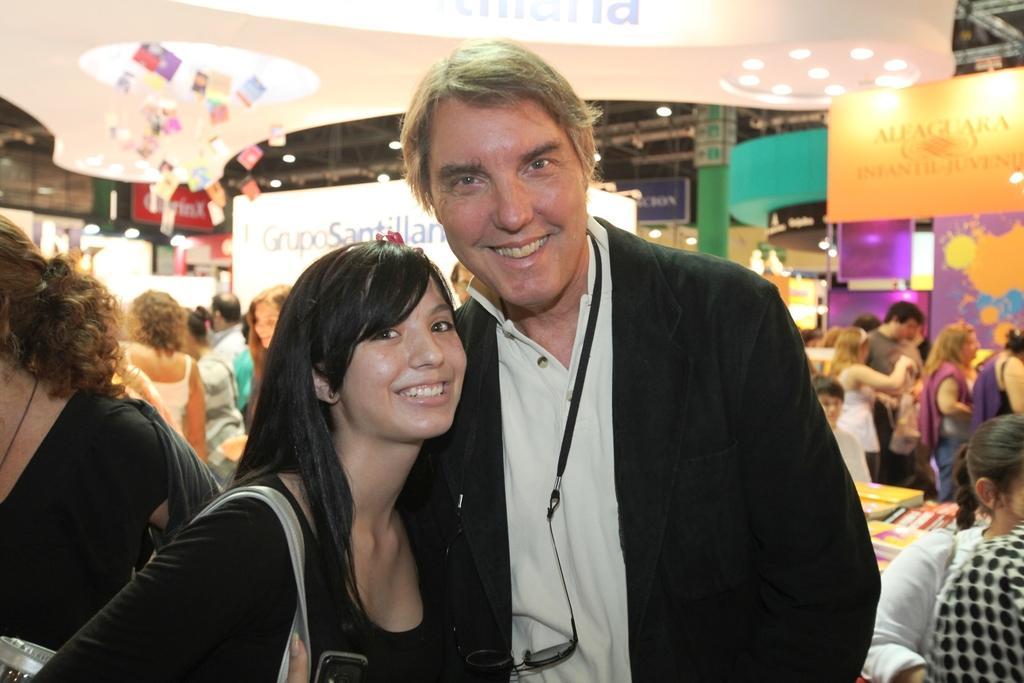In one or two sentences, can you explain what this image depicts? In this image I can see in the middle a woman is smiling, she is wearing a black color t-shirt. Beside her there is a man, he is smiling. At the back side a group of people are there, on the right side there are lights. 